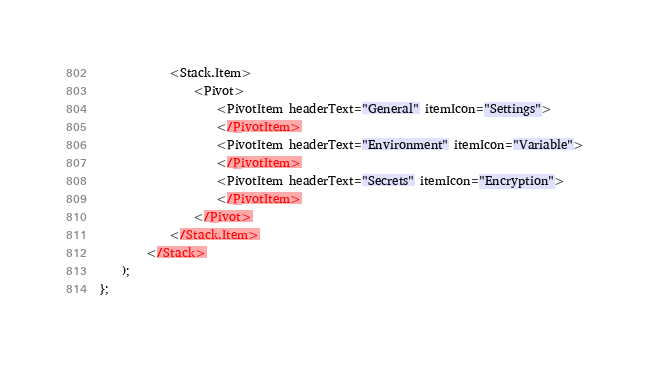<code> <loc_0><loc_0><loc_500><loc_500><_TypeScript_>            <Stack.Item>
                <Pivot>
                    <PivotItem headerText="General" itemIcon="Settings">
                    </PivotItem>
                    <PivotItem headerText="Environment" itemIcon="Variable">
                    </PivotItem>
                    <PivotItem headerText="Secrets" itemIcon="Encryption">
                    </PivotItem>
                </Pivot>
            </Stack.Item>
        </Stack>
    );
};
</code> 